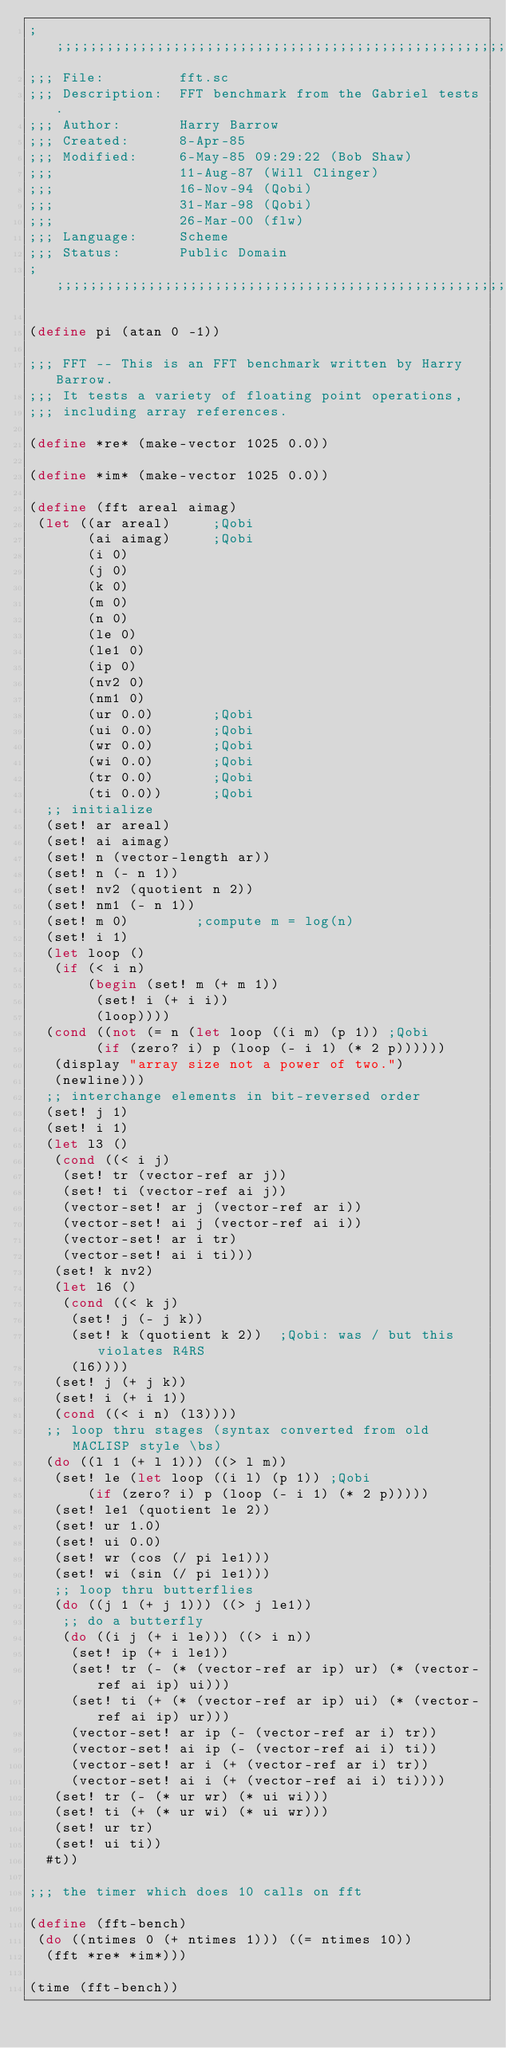<code> <loc_0><loc_0><loc_500><loc_500><_Scheme_>;;;;;;;;;;;;;;;;;;;;;;;;;;;;;;;;;;;;;;;;;;;;;;;;;;;;;;;;;;;;;;;;;;;;;;;;;;;;;;;
;;; File:         fft.sc
;;; Description:  FFT benchmark from the Gabriel tests.
;;; Author:       Harry Barrow
;;; Created:      8-Apr-85
;;; Modified:     6-May-85 09:29:22 (Bob Shaw)
;;;               11-Aug-87 (Will Clinger)
;;;               16-Nov-94 (Qobi)
;;;               31-Mar-98 (Qobi)
;;;               26-Mar-00 (flw)
;;; Language:     Scheme
;;; Status:       Public Domain
;;;;;;;;;;;;;;;;;;;;;;;;;;;;;;;;;;;;;;;;;;;;;;;;;;;;;;;;;;;;;;;;;;;;;;;;;;;;;;;

(define pi (atan 0 -1))

;;; FFT -- This is an FFT benchmark written by Harry Barrow.
;;; It tests a variety of floating point operations,
;;; including array references.

(define *re* (make-vector 1025 0.0))

(define *im* (make-vector 1025 0.0))

(define (fft areal aimag)
 (let ((ar areal)			;Qobi
       (ai aimag)			;Qobi
       (i 0)
       (j 0)
       (k 0)
       (m 0)
       (n 0)
       (le 0)
       (le1 0)
       (ip 0)
       (nv2 0)
       (nm1 0)
       (ur 0.0)				;Qobi
       (ui 0.0)				;Qobi
       (wr 0.0)				;Qobi
       (wi 0.0)				;Qobi
       (tr 0.0)				;Qobi
       (ti 0.0))			;Qobi
  ;; initialize
  (set! ar areal)
  (set! ai aimag)
  (set! n (vector-length ar))
  (set! n (- n 1))
  (set! nv2 (quotient n 2))
  (set! nm1 (- n 1))
  (set! m 0)				;compute m = log(n)
  (set! i 1)
  (let loop ()
   (if (< i n)
       (begin (set! m (+ m 1))
	      (set! i (+ i i))
	      (loop))))
  (cond ((not (= n (let loop ((i m) (p 1)) ;Qobi
		    (if (zero? i) p (loop (- i 1) (* 2 p))))))
	 (display "array size not a power of two.")
	 (newline)))
  ;; interchange elements in bit-reversed order
  (set! j 1)
  (set! i 1)
  (let l3 ()
   (cond ((< i j)
	  (set! tr (vector-ref ar j))
	  (set! ti (vector-ref ai j))
	  (vector-set! ar j (vector-ref ar i))
	  (vector-set! ai j (vector-ref ai i))
	  (vector-set! ar i tr)
	  (vector-set! ai i ti)))
   (set! k nv2)
   (let l6 ()
    (cond ((< k j)
	   (set! j (- j k))
	   (set! k (quotient k 2))	;Qobi: was / but this violates R4RS
	   (l6))))
   (set! j (+ j k))
   (set! i (+ i 1))
   (cond ((< i n) (l3))))
  ;; loop thru stages (syntax converted from old MACLISP style \bs)
  (do ((l 1 (+ l 1))) ((> l m))
   (set! le (let loop ((i l) (p 1))	;Qobi
	     (if (zero? i) p (loop (- i 1) (* 2 p)))))
   (set! le1 (quotient le 2))
   (set! ur 1.0)
   (set! ui 0.0)
   (set! wr (cos (/ pi le1)))
   (set! wi (sin (/ pi le1)))
   ;; loop thru butterflies
   (do ((j 1 (+ j 1))) ((> j le1))
    ;; do a butterfly
    (do ((i j (+ i le))) ((> i n))
     (set! ip (+ i le1))
     (set! tr (- (* (vector-ref ar ip) ur) (* (vector-ref ai ip) ui)))
     (set! ti (+ (* (vector-ref ar ip) ui) (* (vector-ref ai ip) ur)))
     (vector-set! ar ip (- (vector-ref ar i) tr))
     (vector-set! ai ip (- (vector-ref ai i) ti))
     (vector-set! ar i (+ (vector-ref ar i) tr))
     (vector-set! ai i (+ (vector-ref ai i) ti))))
   (set! tr (- (* ur wr) (* ui wi)))
   (set! ti (+ (* ur wi) (* ui wr)))
   (set! ur tr)
   (set! ui ti))
  #t))

;;; the timer which does 10 calls on fft

(define (fft-bench)
 (do ((ntimes 0 (+ ntimes 1))) ((= ntimes 10))
  (fft *re* *im*)))

(time (fft-bench))
</code> 